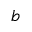Convert formula to latex. <formula><loc_0><loc_0><loc_500><loc_500>b</formula> 